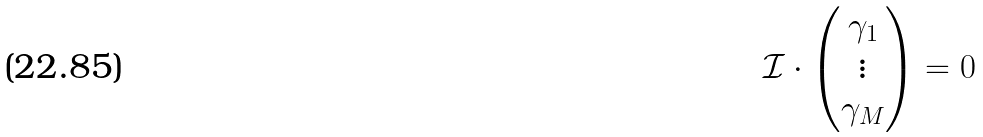<formula> <loc_0><loc_0><loc_500><loc_500>\mathcal { I } \cdot \begin{pmatrix} \gamma _ { 1 } \\ \vdots \\ \gamma _ { M } \end{pmatrix} = 0</formula> 